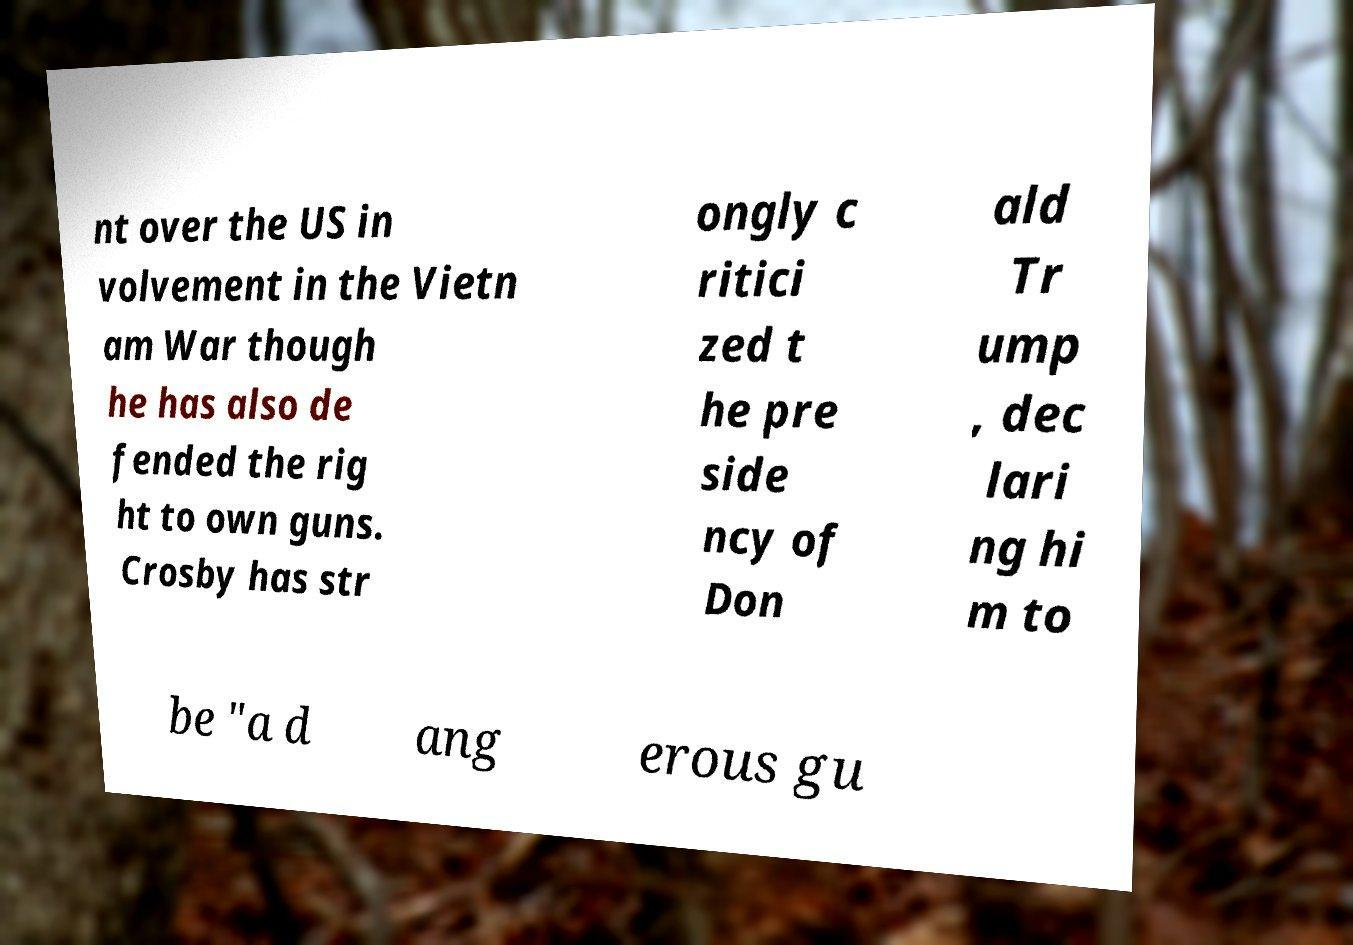Could you assist in decoding the text presented in this image and type it out clearly? nt over the US in volvement in the Vietn am War though he has also de fended the rig ht to own guns. Crosby has str ongly c ritici zed t he pre side ncy of Don ald Tr ump , dec lari ng hi m to be "a d ang erous gu 